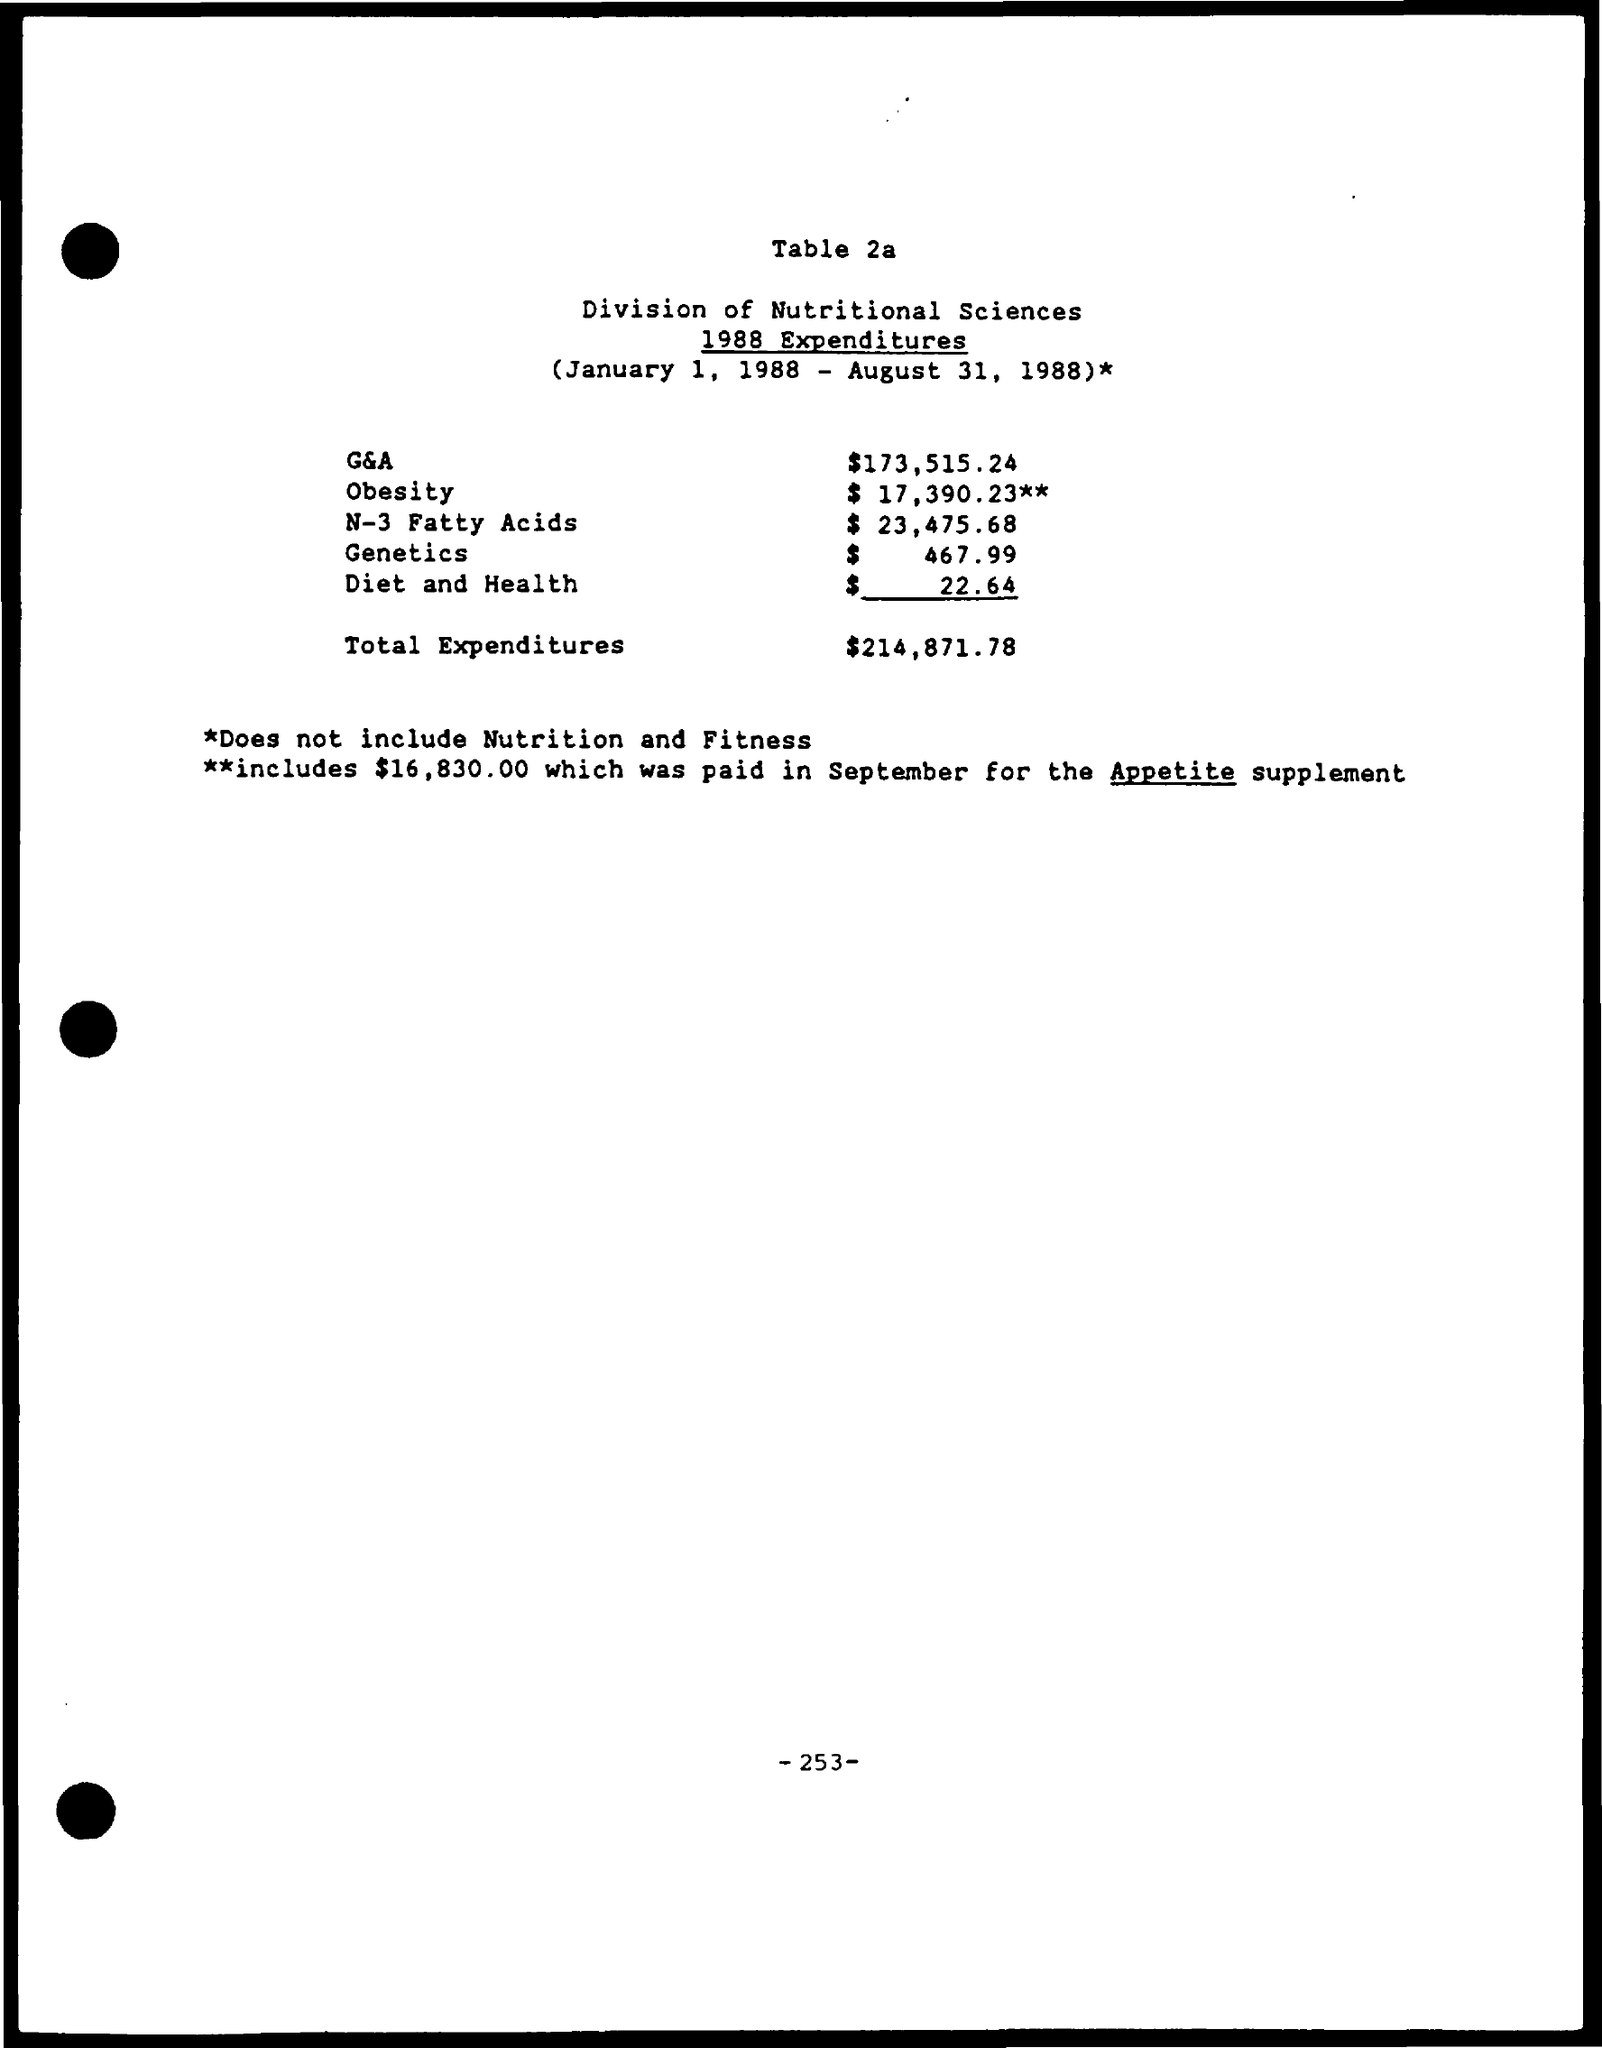Indicate a few pertinent items in this graphic. The G&A is $173,515.24. The expenditure for N-3 fatty acids is $23,475.68. The total expenditures amount to $214,871.78. The expenditure for diet and health is 22.64. The expenditure for obesity is $17,390.23. 